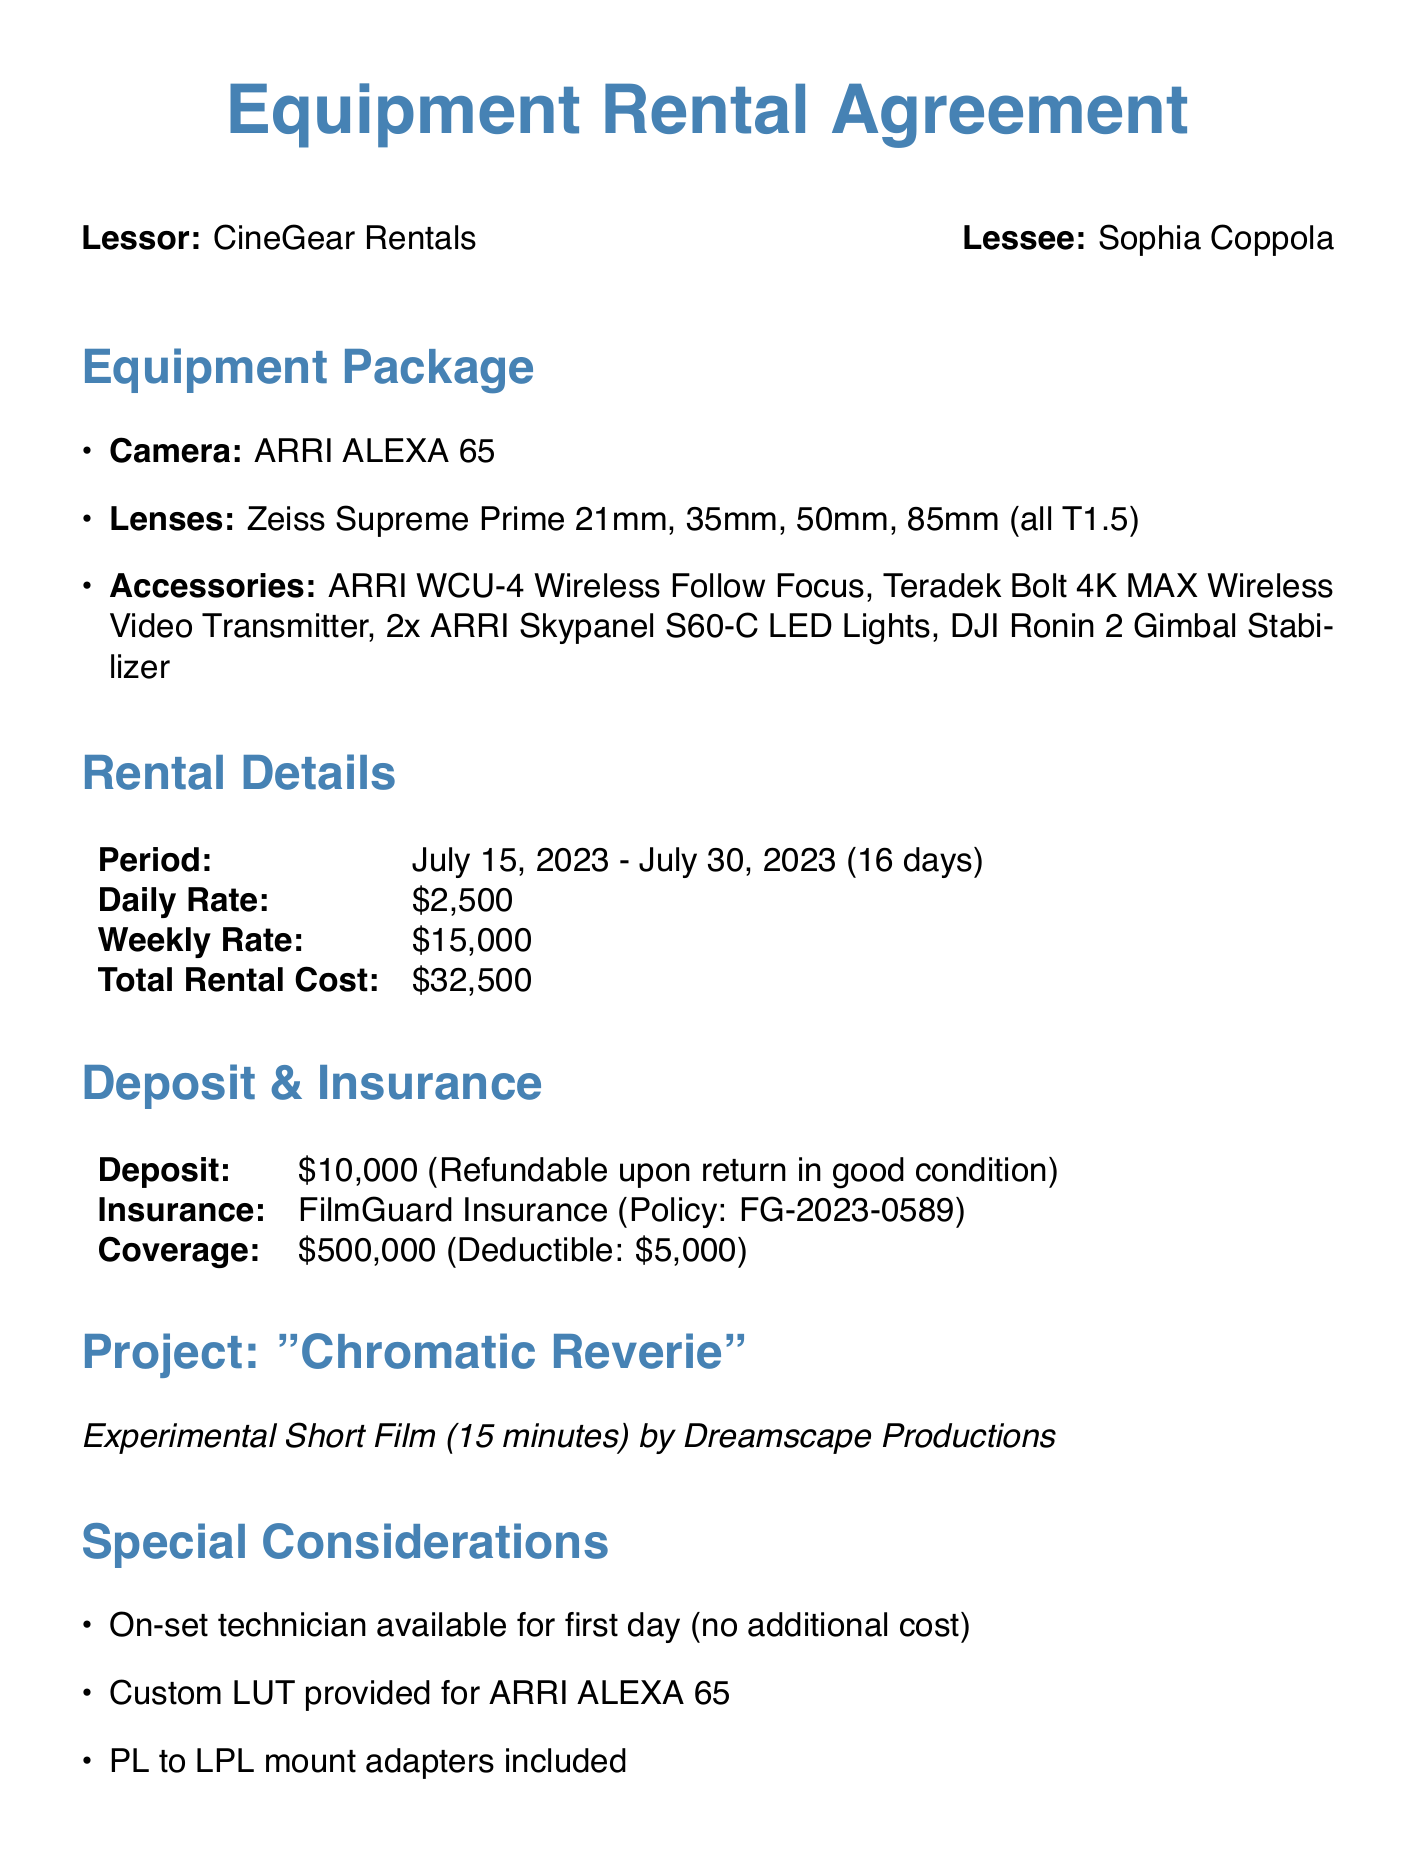What is the name of the lessor? The lessor is mentioned at the beginning of the document as CineGear Rentals.
Answer: CineGear Rentals What is the total rental cost? The total rental cost is listed in the rental rate section of the document as $32,500.
Answer: $32,500 What is the duration of the rental period? The rental period is noted as starting on July 15, 2023, and ending on July 30, 2023. The total duration is 16 days.
Answer: 16 days How much is the refundable deposit? The document states the deposit amount as $10,000, which is refundable upon certain conditions.
Answer: $10,000 What is the maximum coverage amount of the insurance? The coverage amount for the insurance is specified in the insurance section as $500,000.
Answer: $500,000 What is the policy number for the insurance? The insurance policy number is provided as FG-2023-0589 in the document.
Answer: FG-2023-0589 How many different lenses are included in the equipment package? There are four specific lenses listed in the equipment package section of the document.
Answer: Four What happens if equipment is returned late? The additional terms mention that late returns will incur additional daily charges.
Answer: Additional daily charges What is the title of the short film project? The project title is revealed in the project details as "Chromatic Reverie."
Answer: Chromatic Reverie 